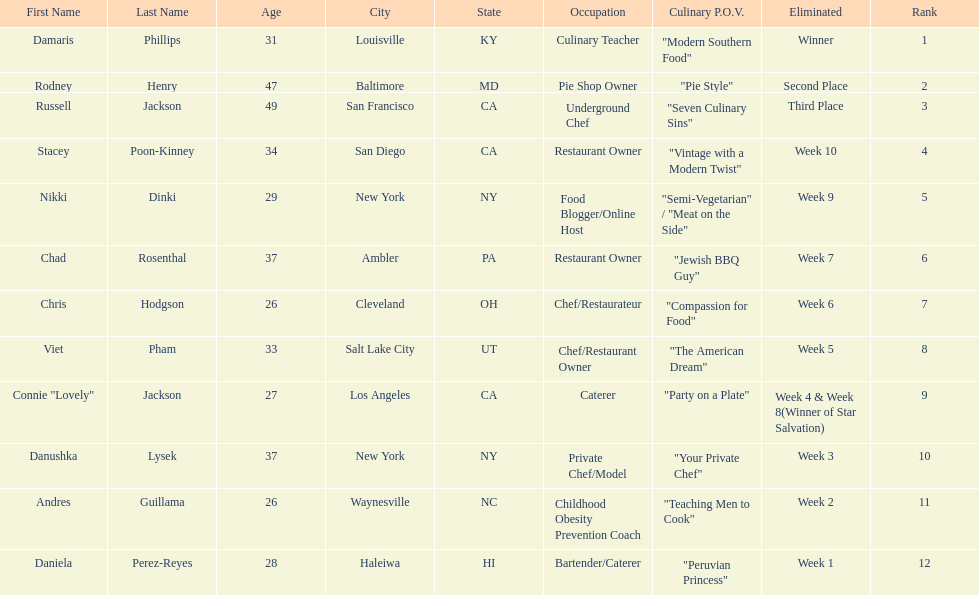Who was eliminated first, nikki dinki or viet pham? Viet Pham. 